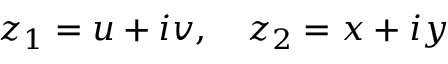Convert formula to latex. <formula><loc_0><loc_0><loc_500><loc_500>z _ { 1 } = u + i v , \quad z _ { 2 } = x + i y</formula> 